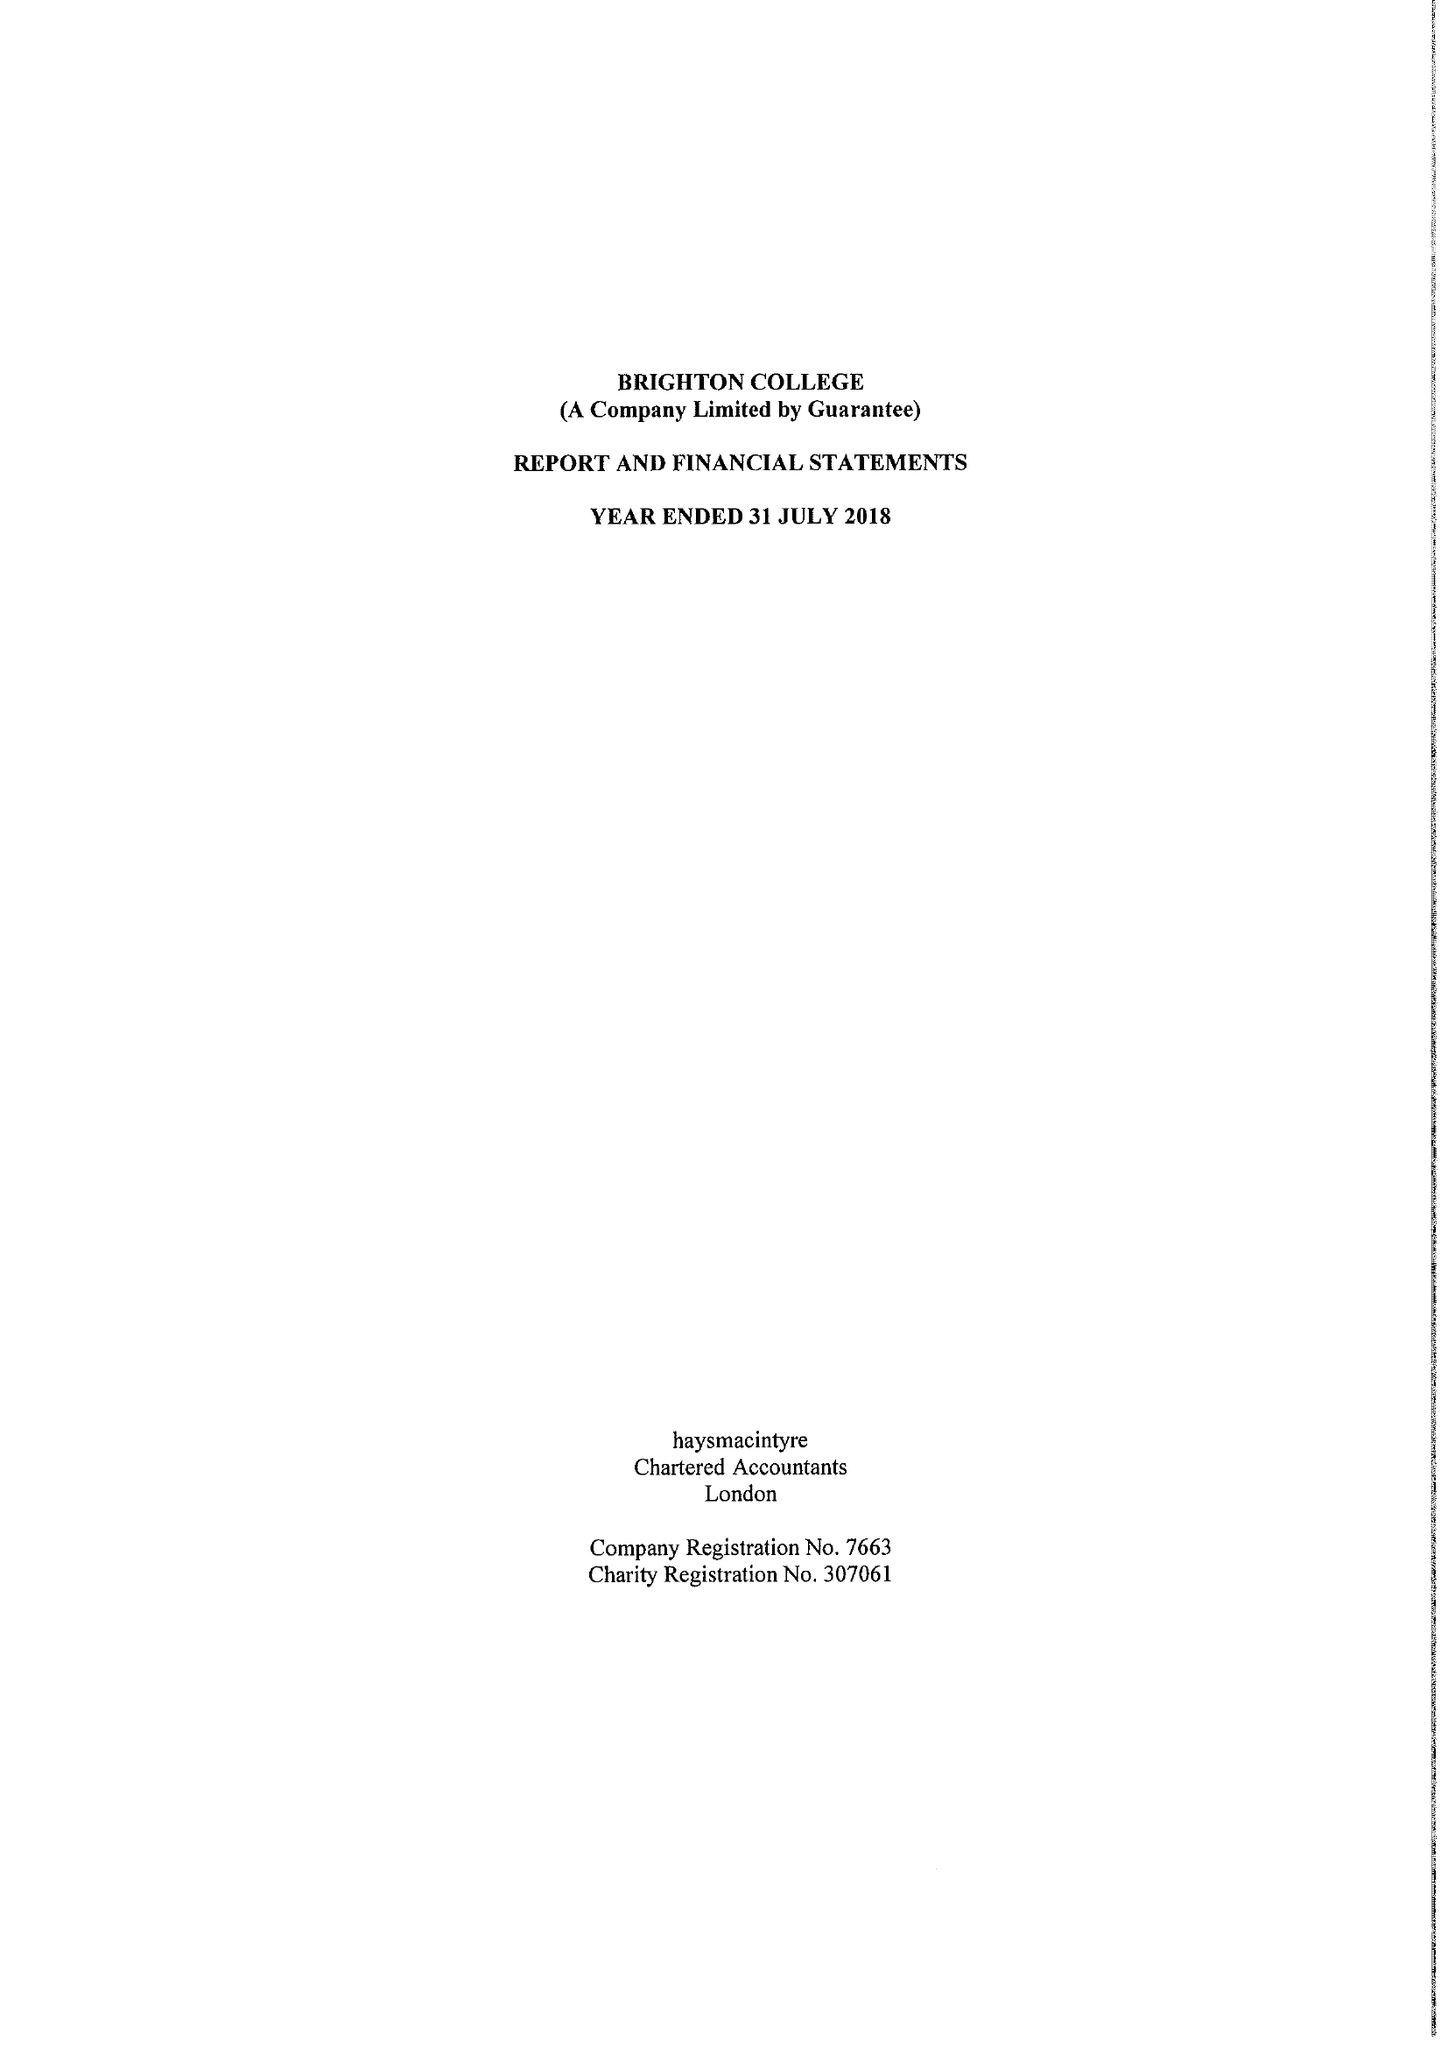What is the value for the income_annually_in_british_pounds?
Answer the question using a single word or phrase. 51714000.00 